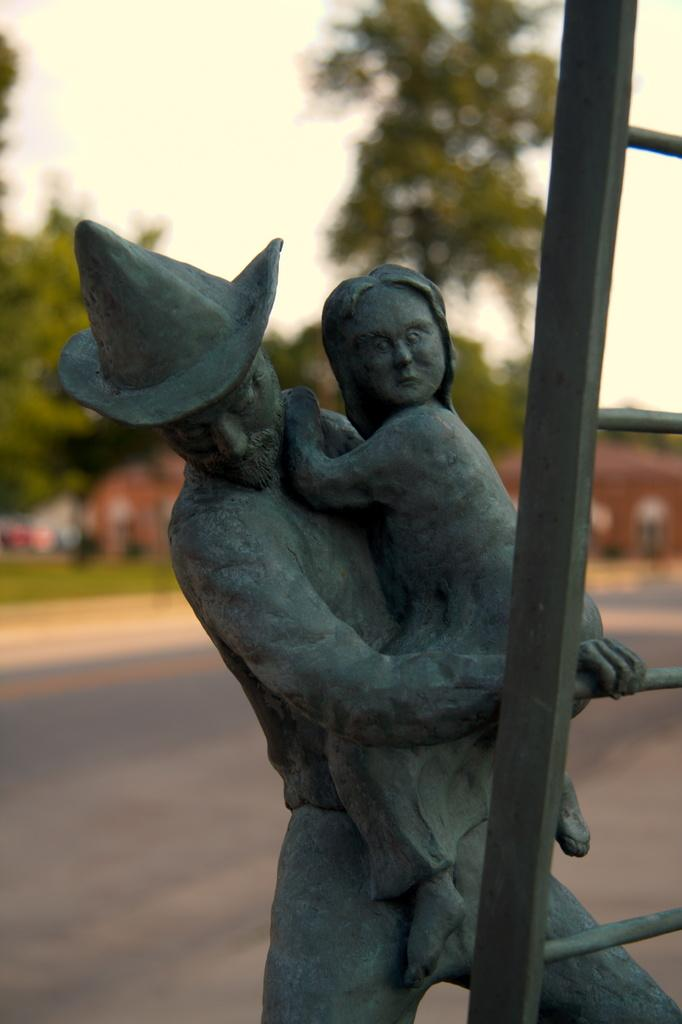What can be seen at the front of the image? There are statues in the front of the image. What object is present that might be used for reaching higher places? There is a ladder in the image. What type of vegetation is visible in the background of the image? There is grass on the ground in the background of the image. What other natural elements can be seen in the background? There are trees in the background of the image. What type of structure is visible in the background? There is a building in the background of the image. What is the color of the building? The building is red in color. What type of produce is being harvested by the bushes in the image? There are no bushes or produce present in the image. What symbol of peace can be seen in the image? There is no symbol of peace depicted in the image. 